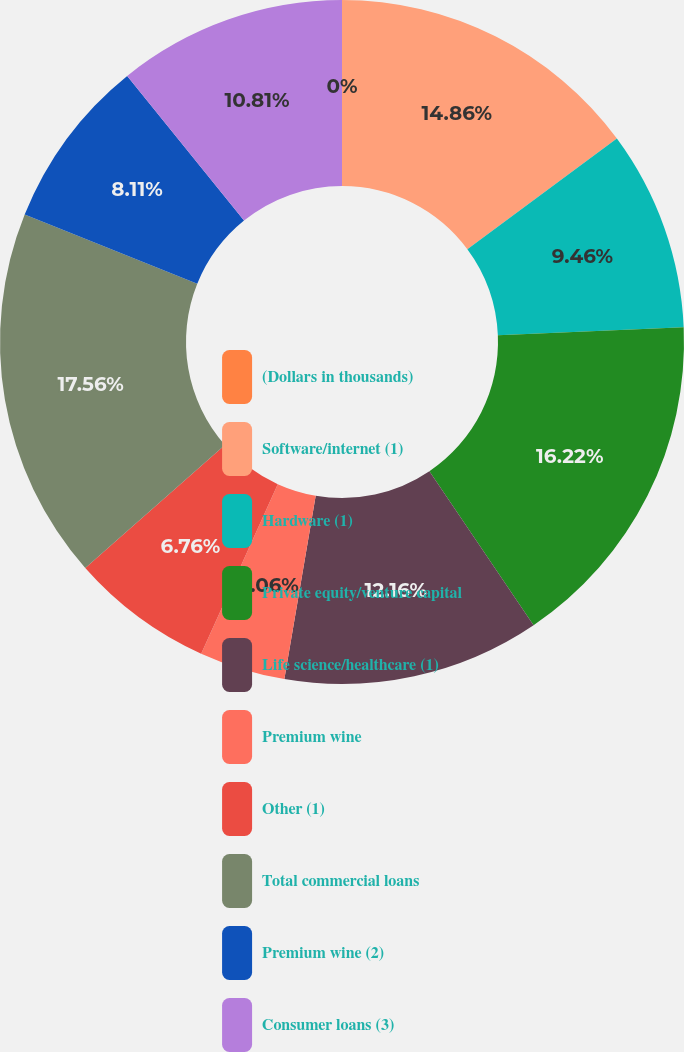<chart> <loc_0><loc_0><loc_500><loc_500><pie_chart><fcel>(Dollars in thousands)<fcel>Software/internet (1)<fcel>Hardware (1)<fcel>Private equity/venture capital<fcel>Life science/healthcare (1)<fcel>Premium wine<fcel>Other (1)<fcel>Total commercial loans<fcel>Premium wine (2)<fcel>Consumer loans (3)<nl><fcel>0.0%<fcel>14.86%<fcel>9.46%<fcel>16.22%<fcel>12.16%<fcel>4.06%<fcel>6.76%<fcel>17.57%<fcel>8.11%<fcel>10.81%<nl></chart> 